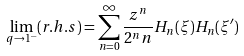<formula> <loc_0><loc_0><loc_500><loc_500>\lim _ { q \rightarrow 1 ^ { - } } ( r . h . s ) = \sum _ { n = 0 } ^ { \infty } \frac { z ^ { n } } { 2 ^ { n } n } H _ { n } ( \xi ) H _ { n } ( \xi ^ { \prime } )</formula> 